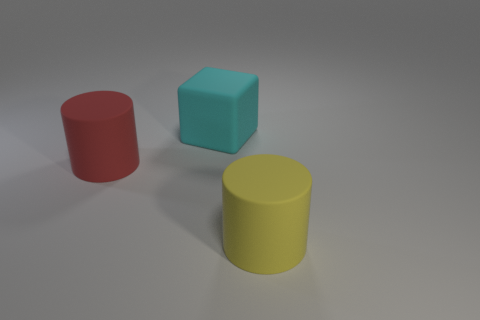Add 1 big cyan objects. How many objects exist? 4 Subtract all cylinders. How many objects are left? 1 Subtract 0 red cubes. How many objects are left? 3 Subtract all large cylinders. Subtract all red objects. How many objects are left? 0 Add 1 large red rubber objects. How many large red rubber objects are left? 2 Add 1 big red things. How many big red things exist? 2 